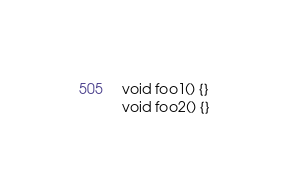<code> <loc_0><loc_0><loc_500><loc_500><_C_>void foo1() {}
void foo2() {}
</code> 